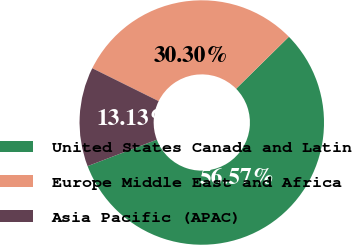<chart> <loc_0><loc_0><loc_500><loc_500><pie_chart><fcel>United States Canada and Latin<fcel>Europe Middle East and Africa<fcel>Asia Pacific (APAC)<nl><fcel>56.57%<fcel>30.3%<fcel>13.13%<nl></chart> 